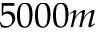<formula> <loc_0><loc_0><loc_500><loc_500>5 0 0 0 m</formula> 